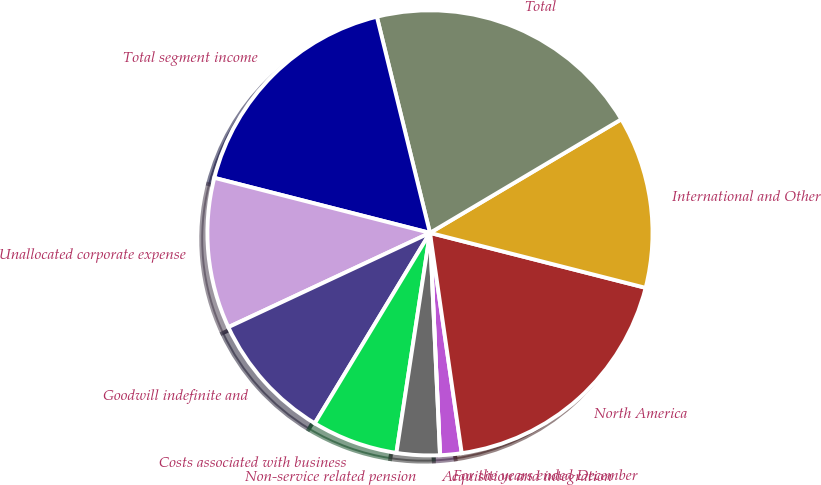Convert chart to OTSL. <chart><loc_0><loc_0><loc_500><loc_500><pie_chart><fcel>For the years ended December<fcel>North America<fcel>International and Other<fcel>Total<fcel>Total segment income<fcel>Unallocated corporate expense<fcel>Goodwill indefinite and<fcel>Costs associated with business<fcel>Non-service related pension<fcel>Acquisition and integration<nl><fcel>1.56%<fcel>18.75%<fcel>12.5%<fcel>20.31%<fcel>17.19%<fcel>10.94%<fcel>9.38%<fcel>6.25%<fcel>3.13%<fcel>0.0%<nl></chart> 